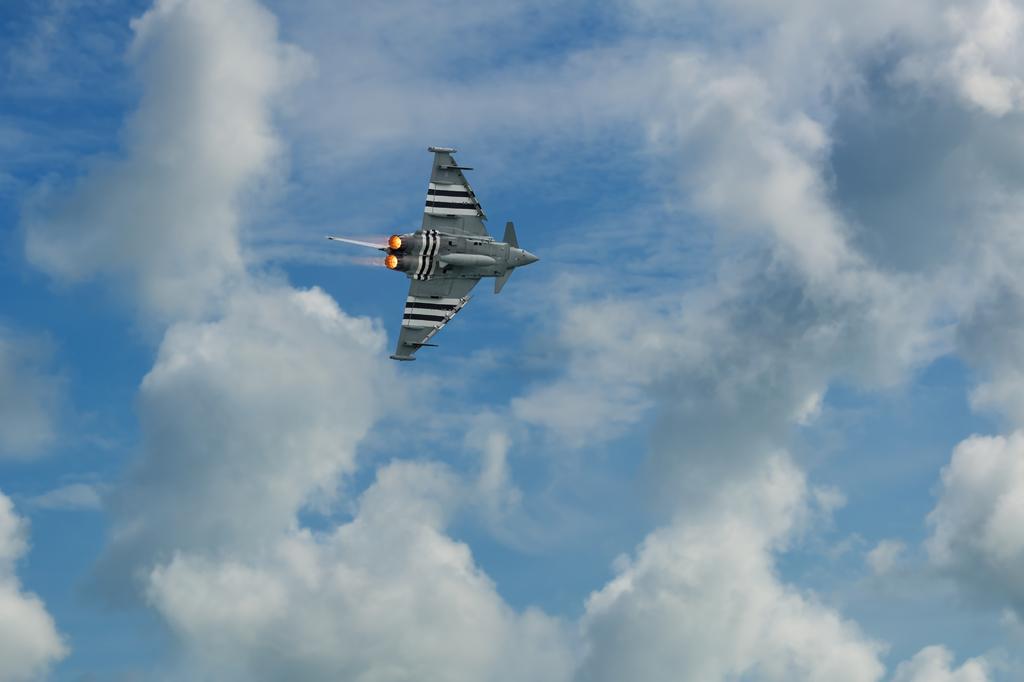In one or two sentences, can you explain what this image depicts? In this picture we can see an airplane in the air. In the background of the image we can see the sky with clouds. 